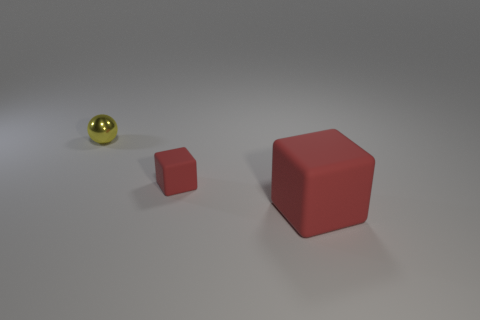Is there anything else that has the same material as the sphere?
Offer a terse response. No. What is the shape of the red rubber thing that is the same size as the metal object?
Provide a succinct answer. Cube. How many matte things are cyan cylinders or tiny yellow spheres?
Offer a terse response. 0. Are the tiny object right of the small yellow sphere and the thing that is left of the tiny red block made of the same material?
Your answer should be very brief. No. What color is the tiny cube that is made of the same material as the large red block?
Your answer should be very brief. Red. Is the number of rubber things to the right of the small rubber thing greater than the number of blocks on the right side of the large red matte block?
Offer a very short reply. Yes. Is there a tiny purple metallic ball?
Your response must be concise. No. There is a small block that is the same color as the large matte object; what material is it?
Provide a succinct answer. Rubber. What number of objects are big matte spheres or yellow objects?
Your response must be concise. 1. Are there any large objects of the same color as the tiny rubber object?
Your answer should be compact. Yes. 